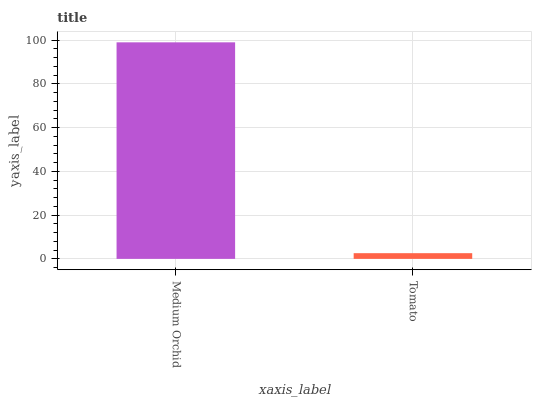Is Tomato the minimum?
Answer yes or no. Yes. Is Medium Orchid the maximum?
Answer yes or no. Yes. Is Tomato the maximum?
Answer yes or no. No. Is Medium Orchid greater than Tomato?
Answer yes or no. Yes. Is Tomato less than Medium Orchid?
Answer yes or no. Yes. Is Tomato greater than Medium Orchid?
Answer yes or no. No. Is Medium Orchid less than Tomato?
Answer yes or no. No. Is Medium Orchid the high median?
Answer yes or no. Yes. Is Tomato the low median?
Answer yes or no. Yes. Is Tomato the high median?
Answer yes or no. No. Is Medium Orchid the low median?
Answer yes or no. No. 